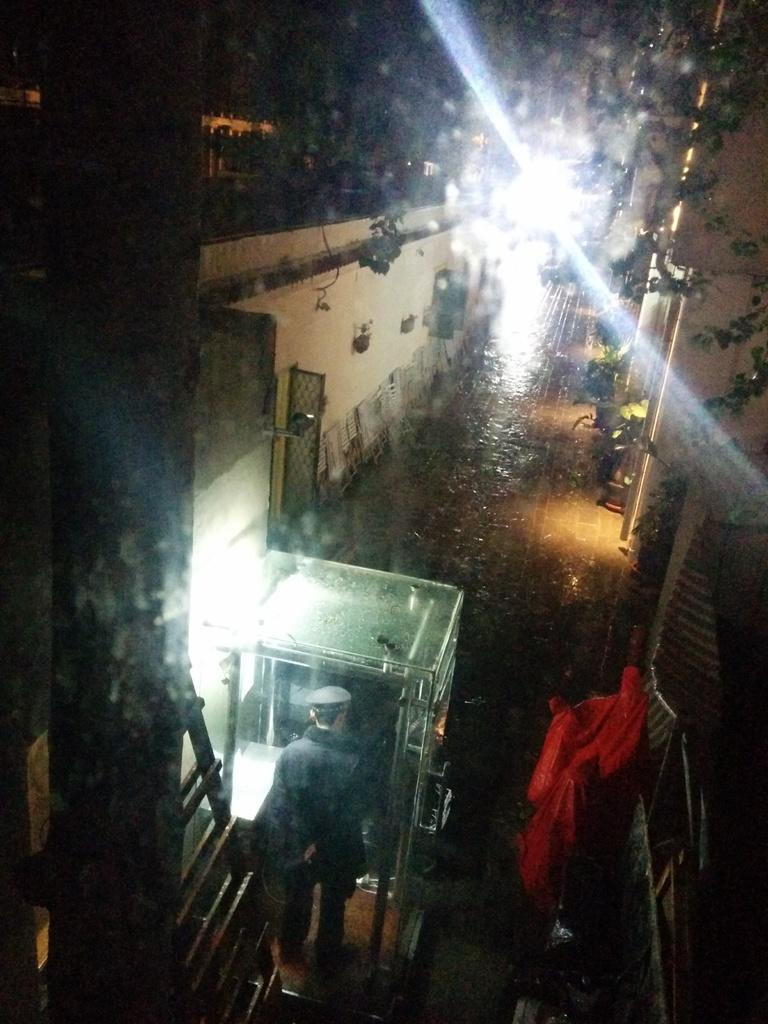Who or what is present in the image? There is a person in the image. What type of structures can be seen in the image? There are buildings in the image. What is the path used for in the image? The path is likely used for walking or traveling in the image. What can be found on the bottom right side of the image? There are objects on the bottom right side of the image. What type of vegetation is present in the image? There are plants in the image. What provides illumination in the image? There are lights in the image. Where is the uncle standing in the image? There is no uncle present in the image. How many sheep are visible in the image? There are no sheep present in the image. 